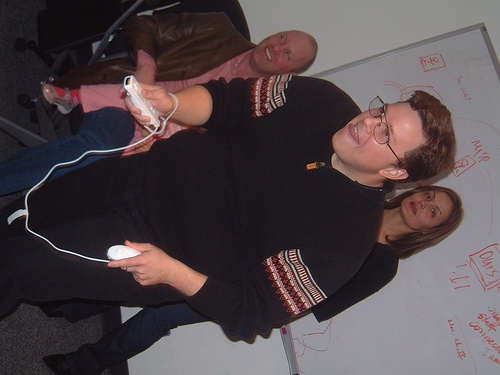Describe the objects in this image and their specific colors. I can see people in black, brown, maroon, and salmon tones, people in black, maroon, and brown tones, people in black, maroon, and brown tones, chair in black and gray tones, and remote in black, lightgray, lightpink, darkgray, and salmon tones in this image. 